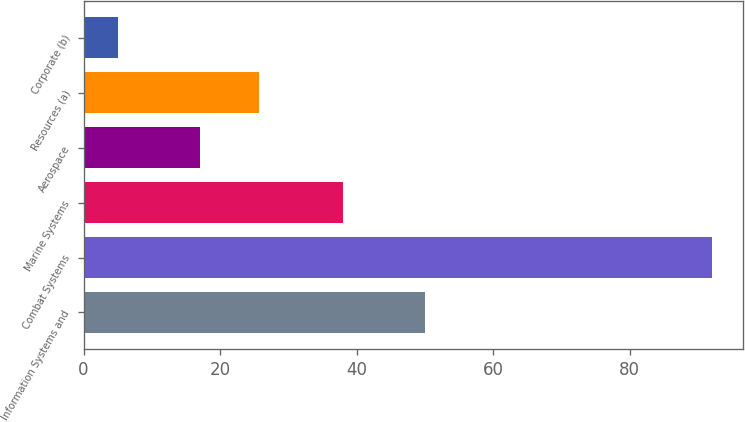Convert chart to OTSL. <chart><loc_0><loc_0><loc_500><loc_500><bar_chart><fcel>Information Systems and<fcel>Combat Systems<fcel>Marine Systems<fcel>Aerospace<fcel>Resources (a)<fcel>Corporate (b)<nl><fcel>50<fcel>92<fcel>38<fcel>17<fcel>25.7<fcel>5<nl></chart> 